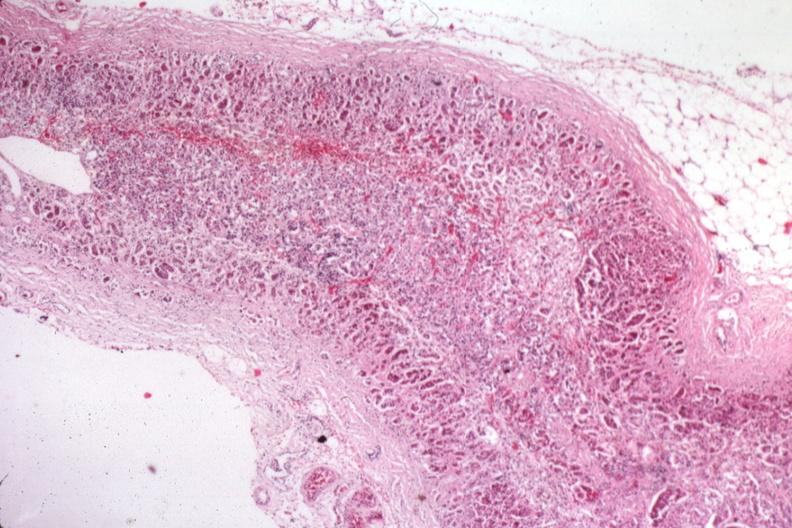s adrenal present?
Answer the question using a single word or phrase. Yes 